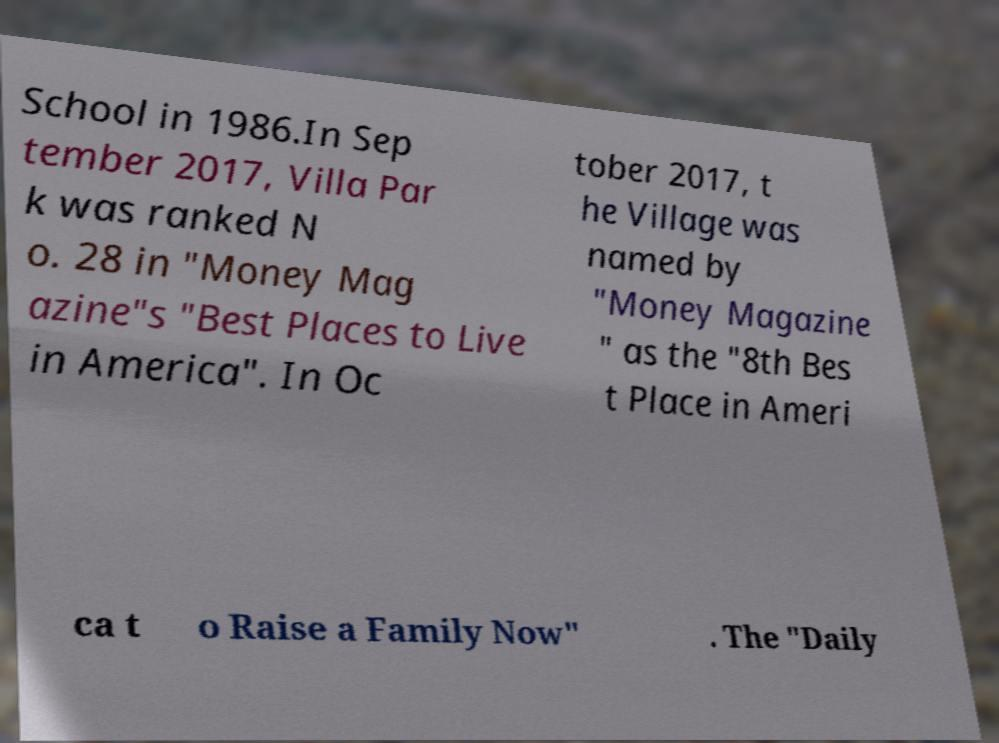Could you extract and type out the text from this image? School in 1986.In Sep tember 2017, Villa Par k was ranked N o. 28 in "Money Mag azine"s "Best Places to Live in America". In Oc tober 2017, t he Village was named by "Money Magazine " as the "8th Bes t Place in Ameri ca t o Raise a Family Now" . The "Daily 